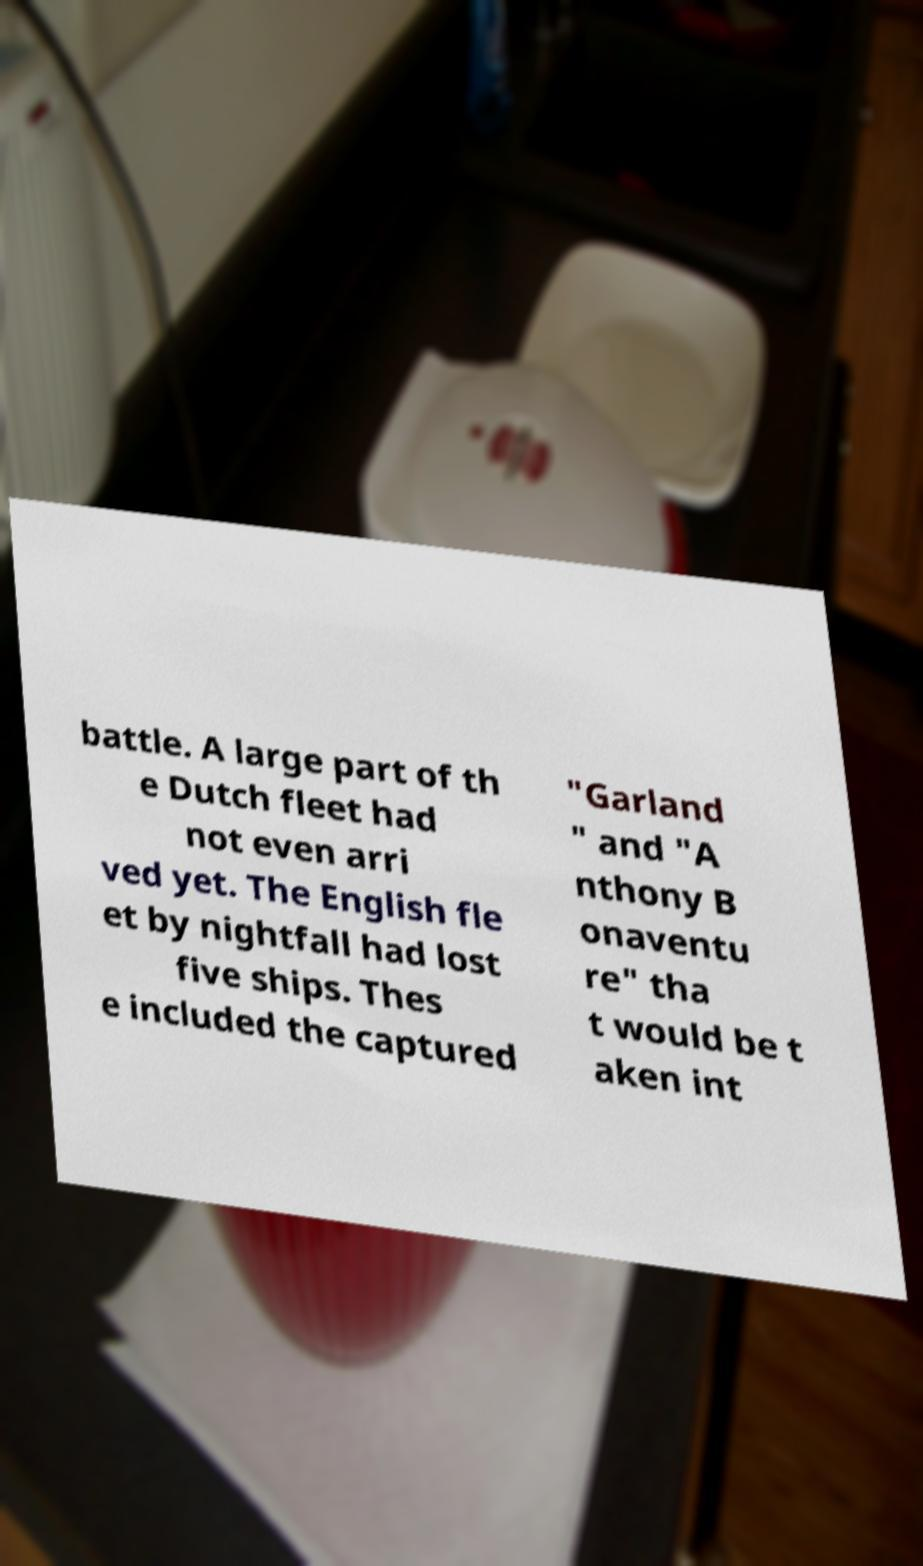Can you read and provide the text displayed in the image?This photo seems to have some interesting text. Can you extract and type it out for me? battle. A large part of th e Dutch fleet had not even arri ved yet. The English fle et by nightfall had lost five ships. Thes e included the captured "Garland " and "A nthony B onaventu re" tha t would be t aken int 